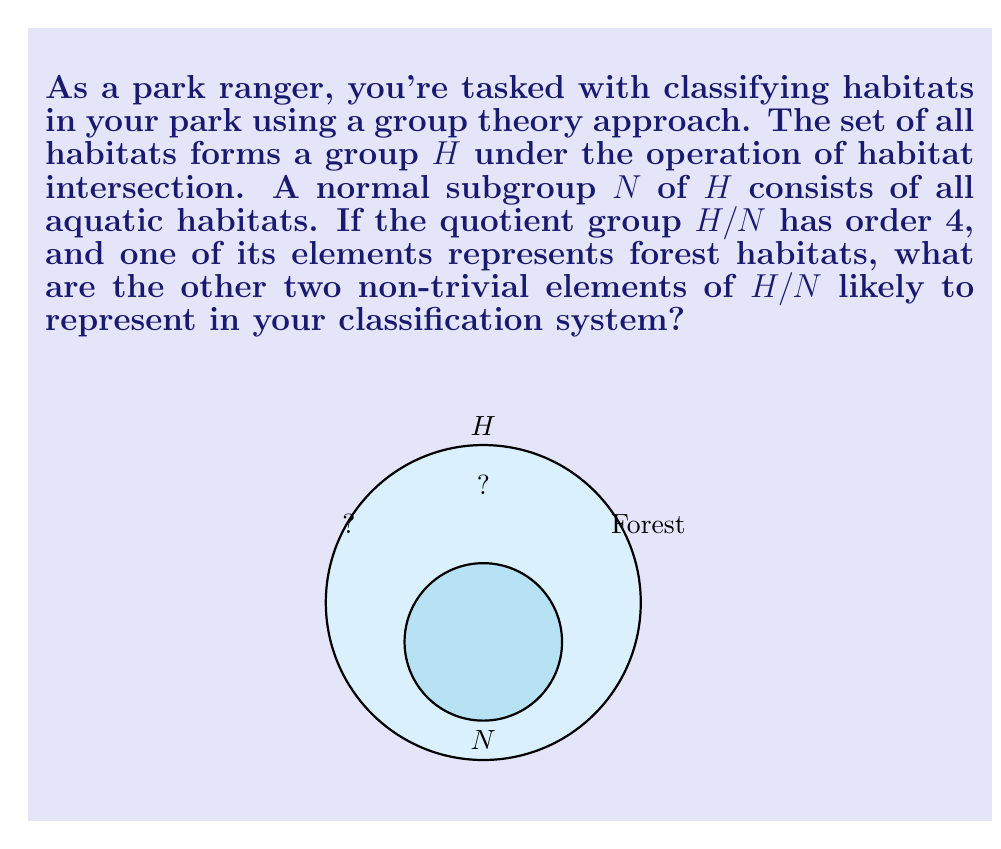Give your solution to this math problem. Let's approach this step-by-step:

1) The quotient group $H/N$ has order 4. This means there are 4 distinct cosets in $H/N$.

2) In a quotient group, one element always represents the identity element. In this case, it would be the coset $N$ itself, representing all aquatic habitats.

3) We're told that one element represents forest habitats. This accounts for two of the four elements in $H/N$.

4) The remaining two elements must represent the other major habitat types in the park that are distinct from aquatic and forest habitats.

5) In a typical park ecosystem, the main habitat types apart from aquatic and forest are:
   - Grassland/Meadow
   - Rocky/Mountainous

6) The Lagrange theorem tells us that the order of each element in $H/N$ must divide the order of the group. Since $|H/N| = 4$, each element must have order 1, 2, or 4.

7) The identity element (aquatic habitats) has order 1. If forest habitats have order 2, then $(forest)^2 = identity$, which doesn't make ecological sense.

8) Therefore, it's likely that forest, grassland, and rocky habitats each have order 4 in $H/N$.

9) This classification system allows for mixed habitats. For example, $(forest)(grassland)$ might represent a savanna-like habitat.
Answer: Grassland and Rocky/Mountainous habitats 